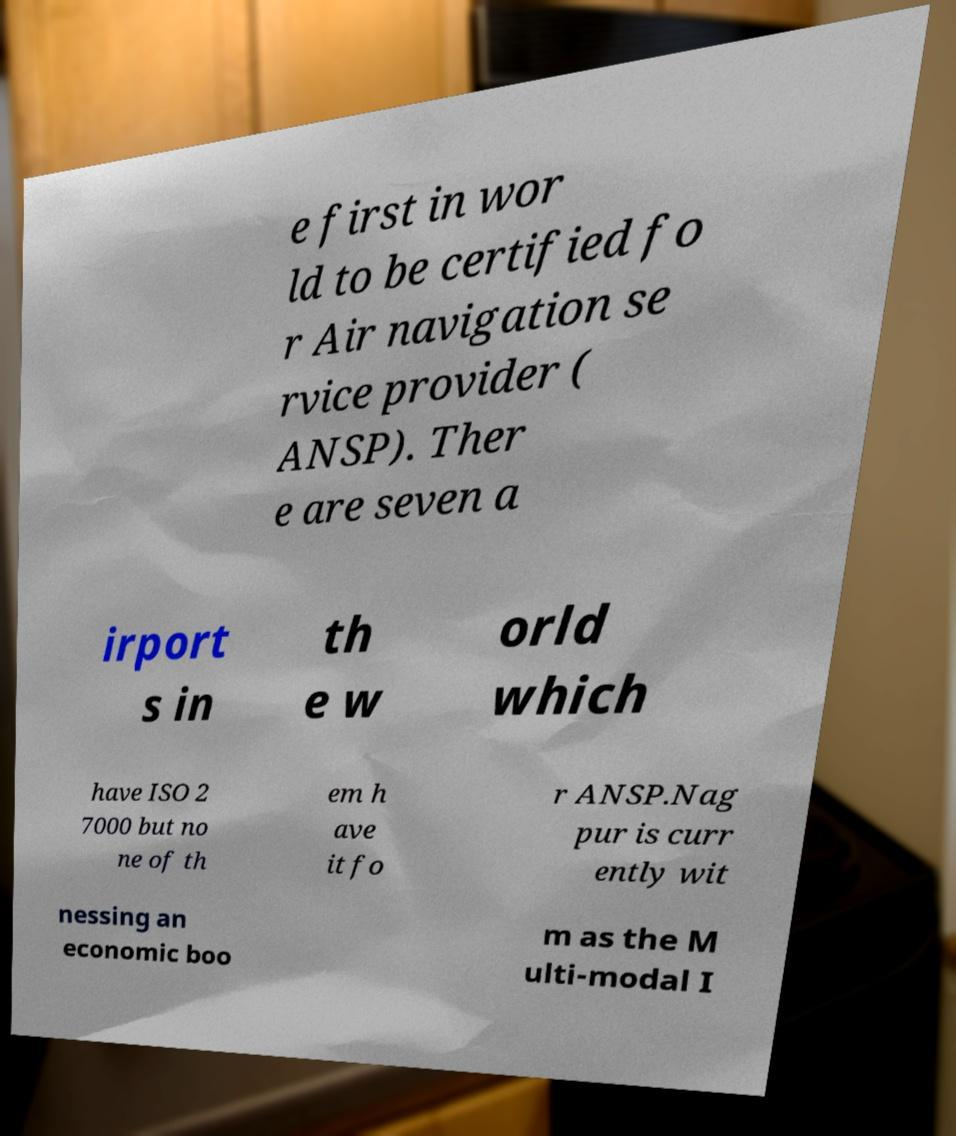I need the written content from this picture converted into text. Can you do that? e first in wor ld to be certified fo r Air navigation se rvice provider ( ANSP). Ther e are seven a irport s in th e w orld which have ISO 2 7000 but no ne of th em h ave it fo r ANSP.Nag pur is curr ently wit nessing an economic boo m as the M ulti-modal I 